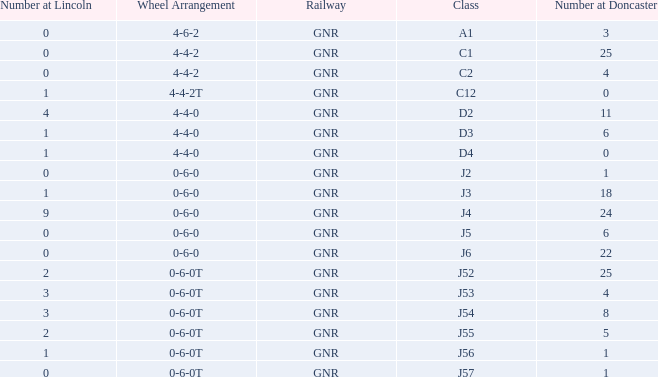Which Class has a Number at Lincoln smaller than 1 and a Wheel Arrangement of 0-6-0? J2, J5, J6. 